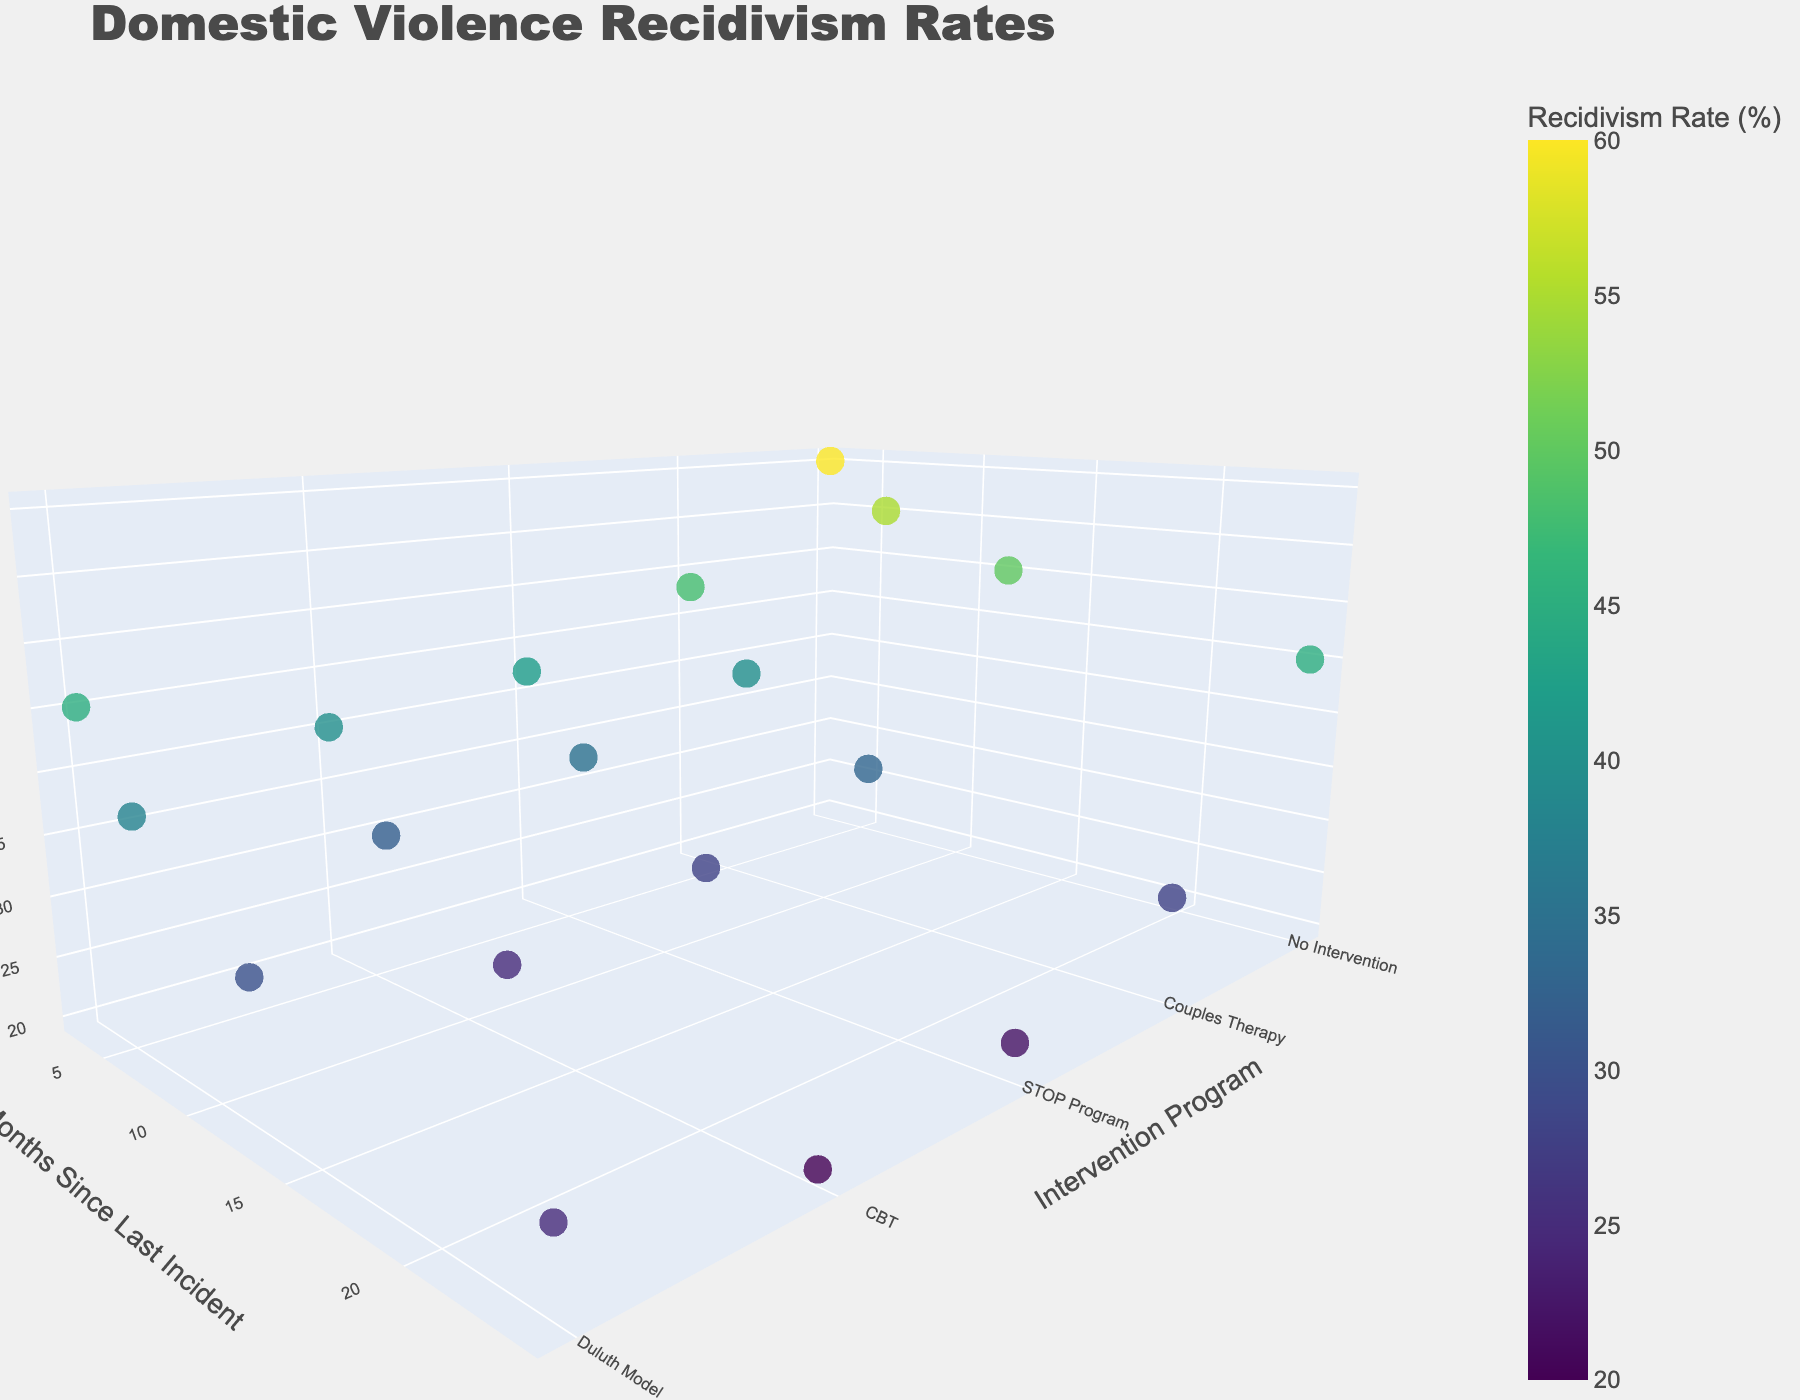What is the title of the 3D plot? The title of the 3D plot is usually displayed prominently at the top of the figure. In this case, from the code, we can see the assigned title is "Domestic Violence Recidivism Rates."
Answer: Domestic Violence Recidivism Rates How many intervention programs are displayed in the plot? To count the number of different intervention programs, we need to identify each distinct label on the y-axis of the scatter plot. The labels provided are "Duluth Model," "CBT," "STOP Program," "Couples Therapy," and "No Intervention," which are five programs in total.
Answer: 5 What's the recidivism rate for "CBT" at 12 months since the last incident? Locate the data point where the "Intervention Program" is "CBT" and "Months Since Last Incident" is 12. The corresponding "Recidivism Rate" is 25.
Answer: 25 Which intervention program has the highest recidivism rate at 3 months since the last incident? Start by looking at only the data points where "Months Since Last Incident" is 3. Compare the recidivism rates for the programs: "Duluth Model" (45), "CBT" (40), "STOP Program" (42), "Couples Therapy" (48), and "No Intervention" (60). The highest rate is 60 for "No Intervention."
Answer: No Intervention How does the recidivism rate change for "Duluth Model" from 3 months to 24 months? Find the recidivism rates for "Duluth Model" at 3 months (45) and at 24 months (25). The difference between these two points shows a decrease from 45 to 25.
Answer: Decreases What is the average recidivism rate for the "STOP Program"? Find the recidivism rates of the "STOP Program" at all given months: 42, 35, 28, and 22. Add the rates to get the total: 42 + 35 + 28 + 22 = 127. Divide by the number of data points (4) to get the average: 127 / 4 = 31.75.
Answer: 31.75 Which intervention program shows the largest decrease in recidivism rate from 3 months to 24 months? Calculate the decrease for each program by subtracting the 3-month recidivism rate from the 24-month rate: "Duluth Model": 45 - 25 = 20, "CBT": 40 - 20 = 20, "STOP Program": 42 - 22 = 20, "Couples Therapy": 48 - 28 = 20, and "No Intervention": 60 - 45 = 15. All programs except "No Intervention" show the same largest decrease of 20.
Answer: Duluth Model, CBT, STOP Program, Couples Therapy Which intervention program has the lowest recidivism rate at 24 months since the last incident? Compare the recidivism rates of all programs at 24 months: "Duluth Model" (25), "CBT" (20), "STOP Program" (22), "Couples Therapy" (28), and "No Intervention" (45). The lowest rate is 20, associated with "CBT."
Answer: CBT What's the recidivism rate difference between "CBT" and "Couples Therapy" at 6 months since the last incident? Find the recidivism rates for "CBT" (32) and "Couples Therapy" (40) at 6 months. Calculate the difference by subtracting the lower value from the higher: 40 - 32 = 8.
Answer: 8 